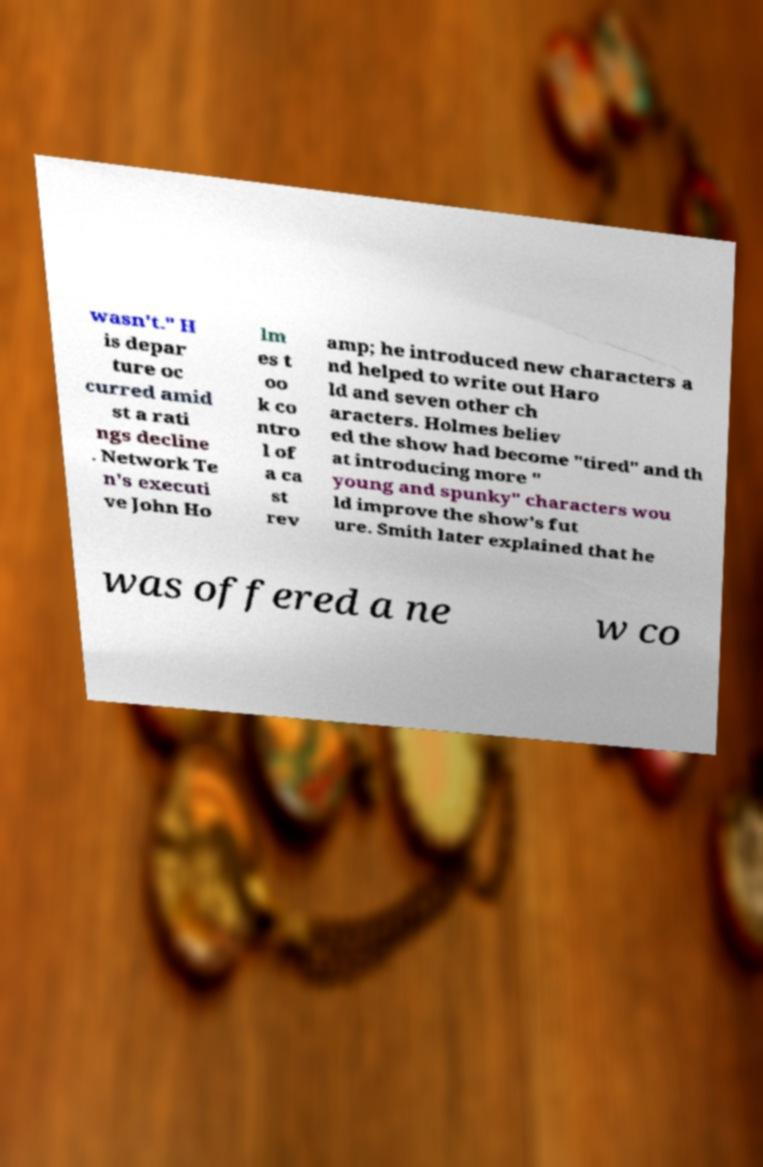Please read and relay the text visible in this image. What does it say? wasn't." H is depar ture oc curred amid st a rati ngs decline . Network Te n's executi ve John Ho lm es t oo k co ntro l of a ca st rev amp; he introduced new characters a nd helped to write out Haro ld and seven other ch aracters. Holmes believ ed the show had become "tired" and th at introducing more " young and spunky" characters wou ld improve the show's fut ure. Smith later explained that he was offered a ne w co 